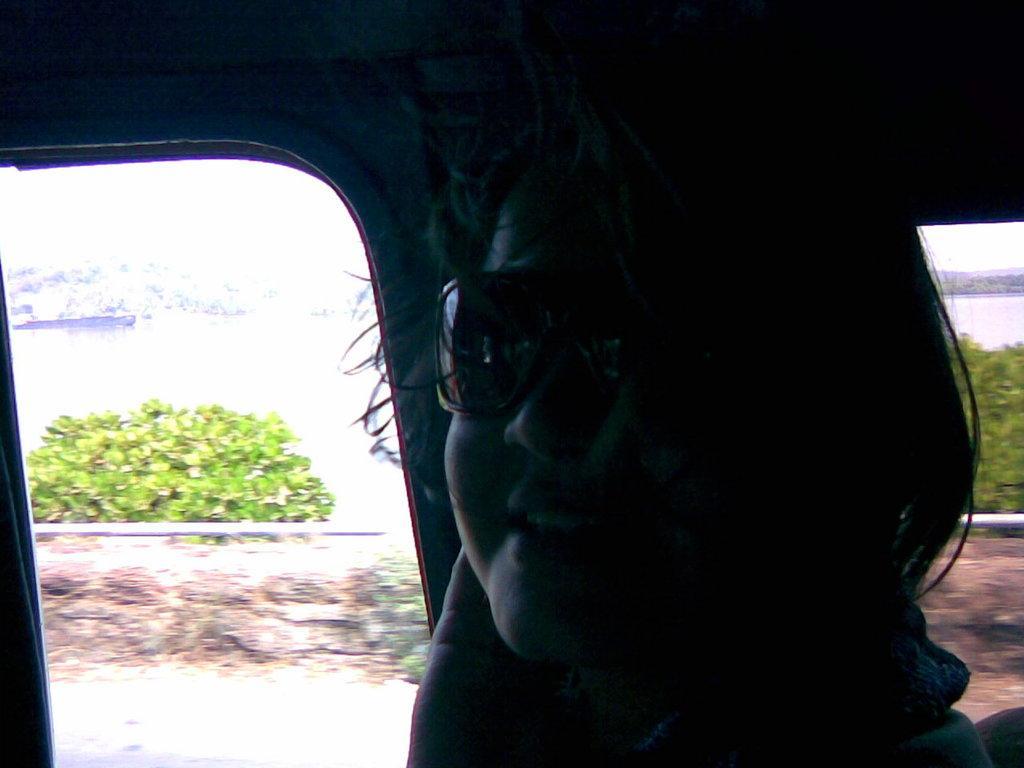Could you give a brief overview of what you see in this image? The picture is taken in a vehicle. In the foreground of the picture there is a person wearing spectacles. In the background there are plants, pipe, wall and trees. 